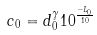<formula> <loc_0><loc_0><loc_500><loc_500>c _ { 0 } = d _ { 0 } ^ { \gamma } 1 0 ^ { \frac { - L _ { 0 } } { 1 0 } }</formula> 